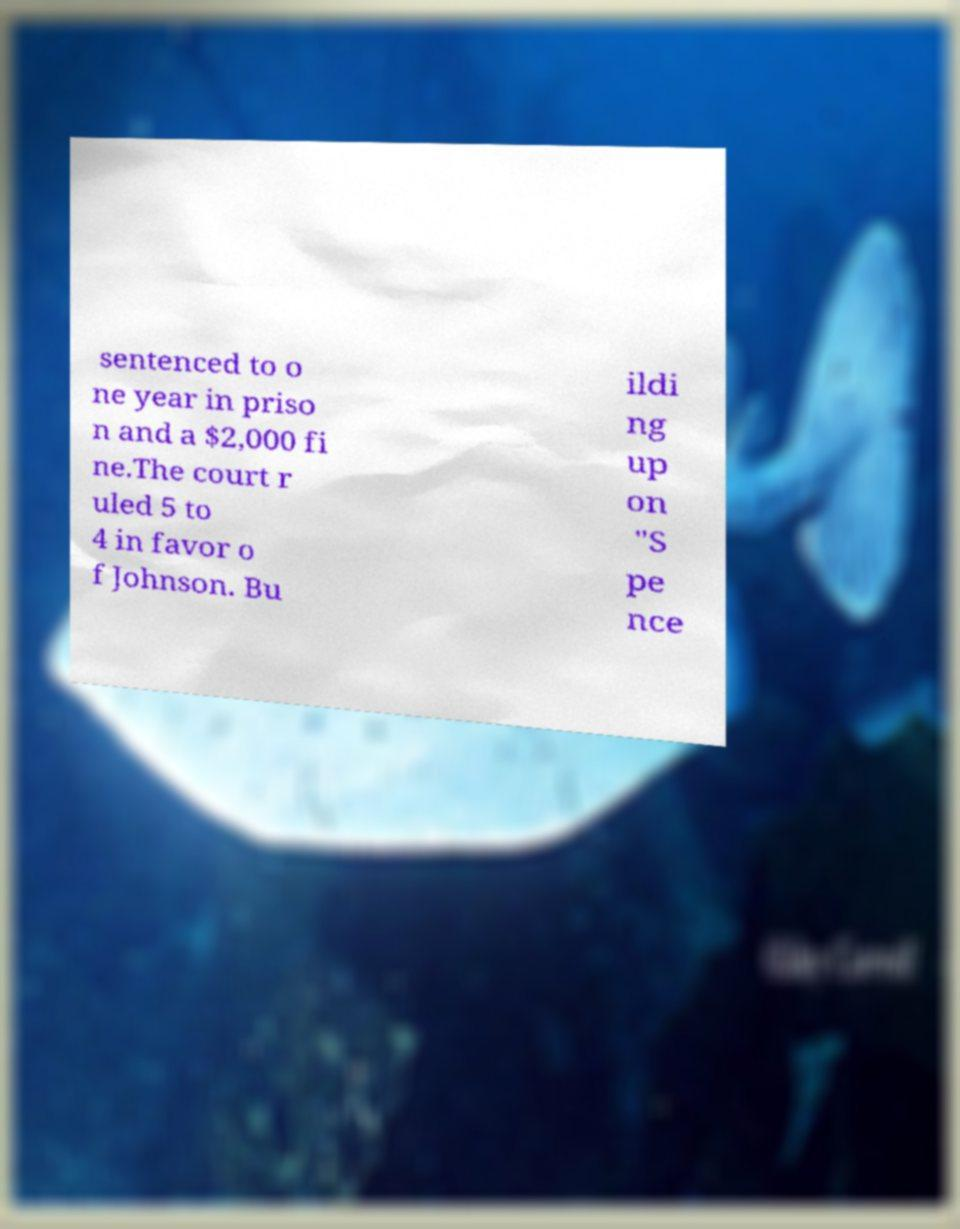There's text embedded in this image that I need extracted. Can you transcribe it verbatim? sentenced to o ne year in priso n and a $2,000 fi ne.The court r uled 5 to 4 in favor o f Johnson. Bu ildi ng up on "S pe nce 